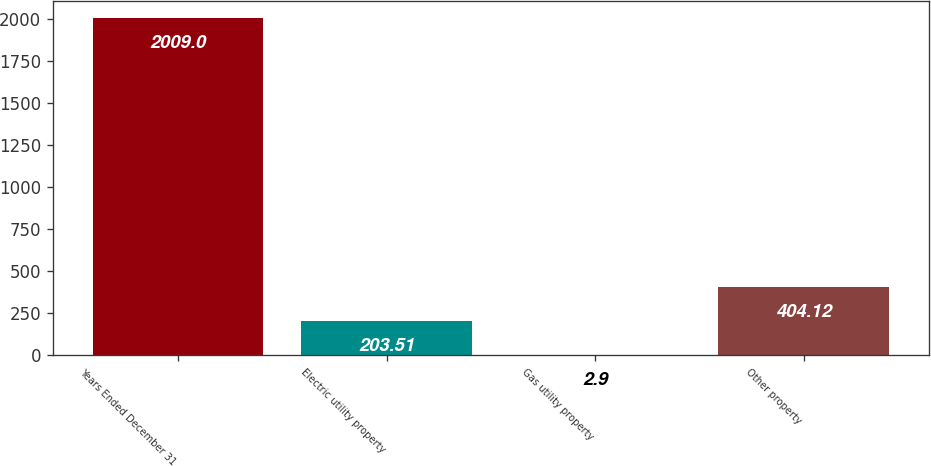<chart> <loc_0><loc_0><loc_500><loc_500><bar_chart><fcel>Years Ended December 31<fcel>Electric utility property<fcel>Gas utility property<fcel>Other property<nl><fcel>2009<fcel>203.51<fcel>2.9<fcel>404.12<nl></chart> 